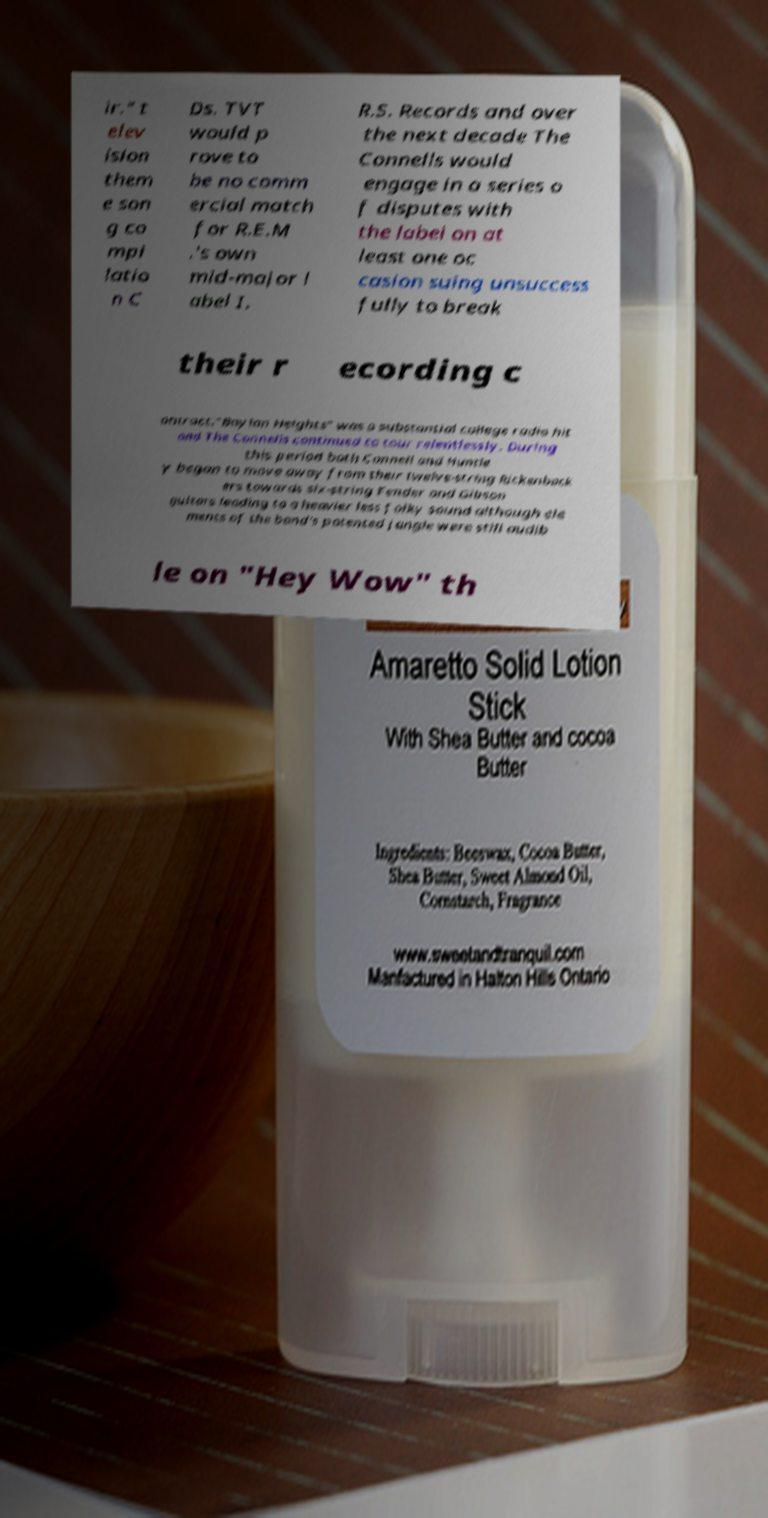Please read and relay the text visible in this image. What does it say? ir." t elev ision them e son g co mpi latio n C Ds. TVT would p rove to be no comm ercial match for R.E.M .'s own mid-major l abel I. R.S. Records and over the next decade The Connells would engage in a series o f disputes with the label on at least one oc casion suing unsuccess fully to break their r ecording c ontract."Boylan Heights" was a substantial college radio hit and The Connells continued to tour relentlessly. During this period both Connell and Huntle y began to move away from their twelve-string Rickenback ers towards six-string Fender and Gibson guitars leading to a heavier less folky sound although ele ments of the band's patented jangle were still audib le on "Hey Wow" th 